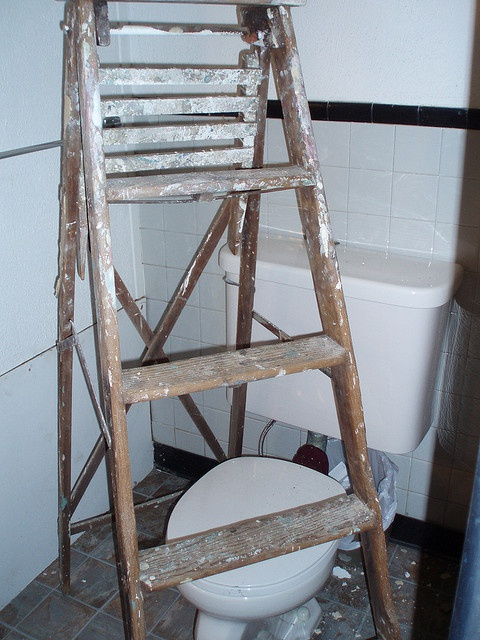Describe the objects in this image and their specific colors. I can see a toilet in darkgray and lightgray tones in this image. 